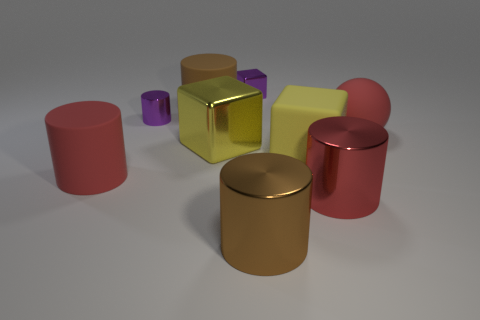Is the small block made of the same material as the brown cylinder behind the tiny metallic cylinder?
Make the answer very short. No. There is a small metal object that is to the right of the yellow shiny block; is its color the same as the ball?
Keep it short and to the point. No. There is a cube that is both right of the yellow metallic thing and in front of the purple cylinder; what is its material?
Provide a short and direct response. Rubber. What size is the yellow matte cube?
Provide a short and direct response. Large. Do the tiny cylinder and the cylinder to the right of the brown shiny cylinder have the same color?
Ensure brevity in your answer.  No. How many other things are the same color as the large matte sphere?
Provide a short and direct response. 2. There is a brown metal thing that is right of the purple metal cube; does it have the same size as the brown cylinder that is behind the large shiny cube?
Provide a short and direct response. Yes. There is a sphere that is to the right of the big red matte cylinder; what is its color?
Give a very brief answer. Red. Is the number of large brown objects that are behind the small purple block less than the number of brown matte things?
Offer a very short reply. Yes. Is the sphere made of the same material as the small cylinder?
Provide a succinct answer. No. 